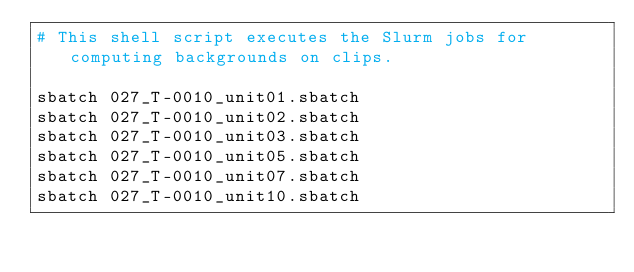<code> <loc_0><loc_0><loc_500><loc_500><_Bash_># This shell script executes the Slurm jobs for computing backgrounds on clips.

sbatch 027_T-0010_unit01.sbatch
sbatch 027_T-0010_unit02.sbatch
sbatch 027_T-0010_unit03.sbatch
sbatch 027_T-0010_unit05.sbatch
sbatch 027_T-0010_unit07.sbatch
sbatch 027_T-0010_unit10.sbatch
</code> 